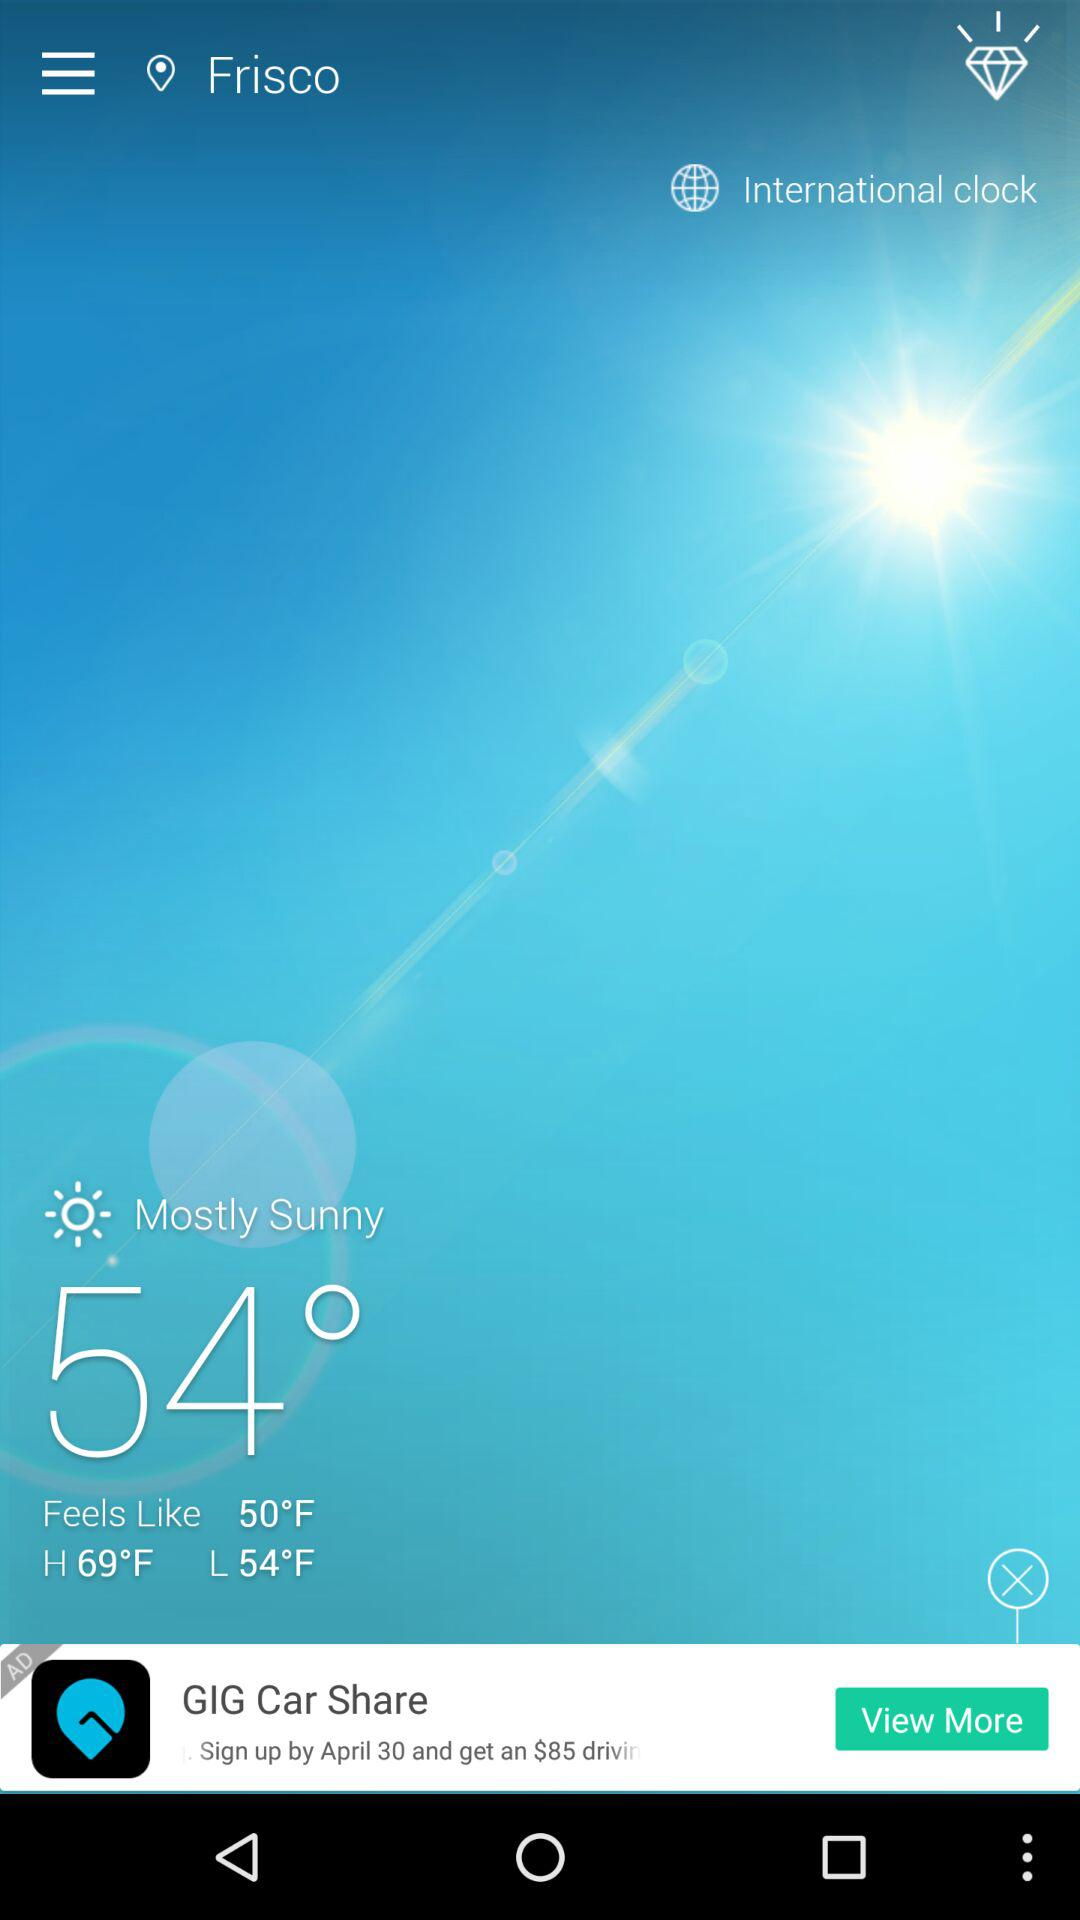What is the name of the application?
When the provided information is insufficient, respond with <no answer>. <no answer> 